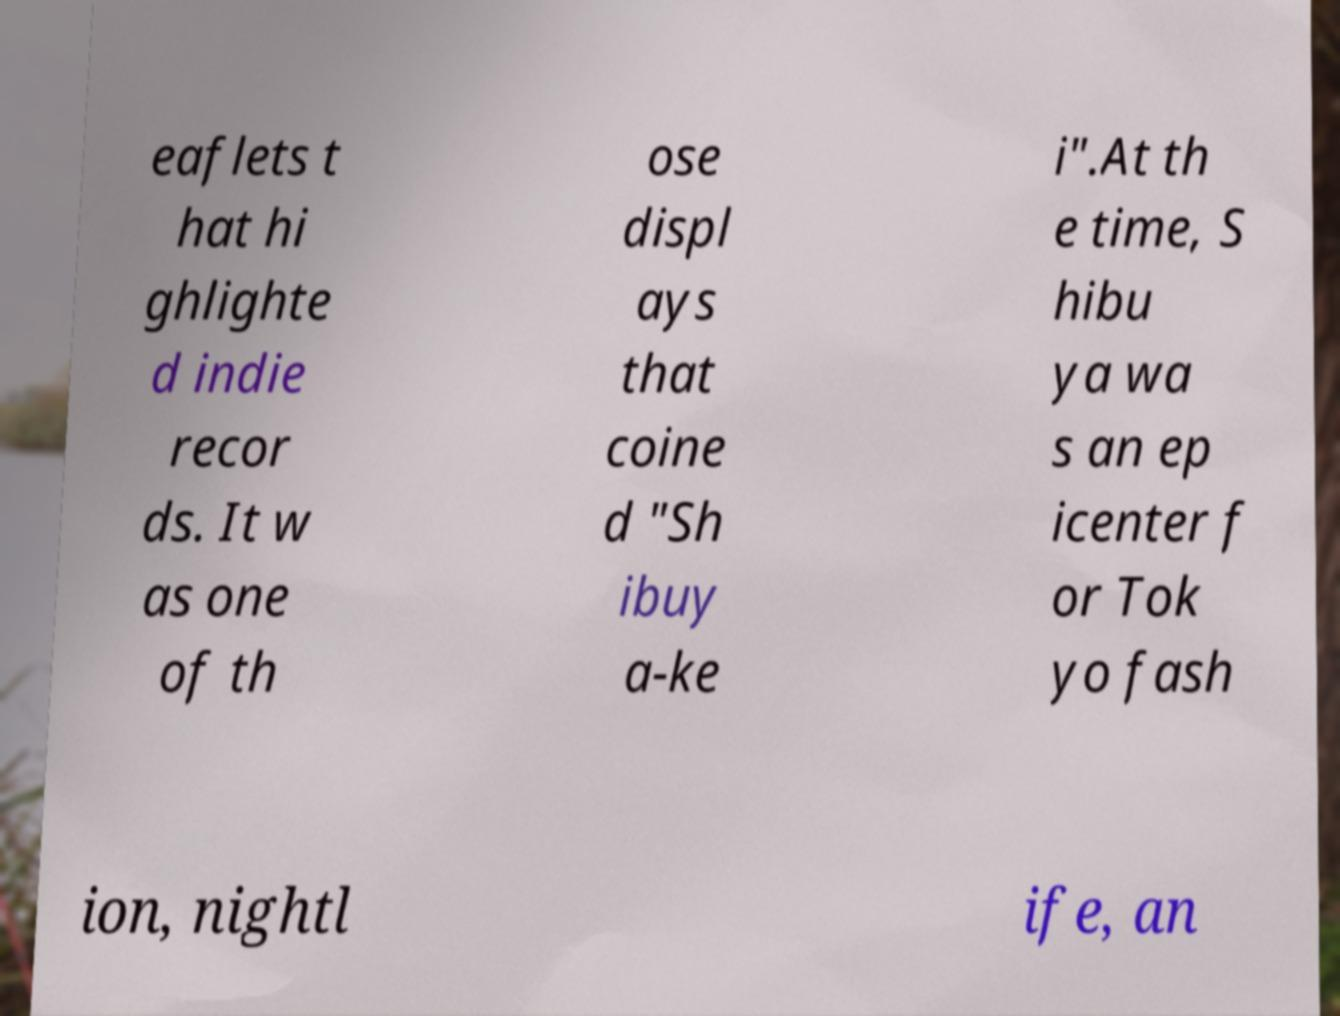I need the written content from this picture converted into text. Can you do that? eaflets t hat hi ghlighte d indie recor ds. It w as one of th ose displ ays that coine d "Sh ibuy a-ke i".At th e time, S hibu ya wa s an ep icenter f or Tok yo fash ion, nightl ife, an 